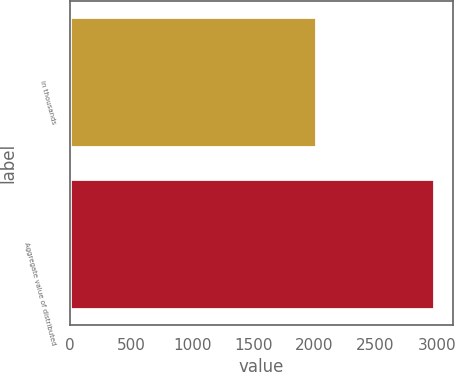Convert chart. <chart><loc_0><loc_0><loc_500><loc_500><bar_chart><fcel>in thousands<fcel>Aggregate value of distributed<nl><fcel>2010<fcel>2981<nl></chart> 